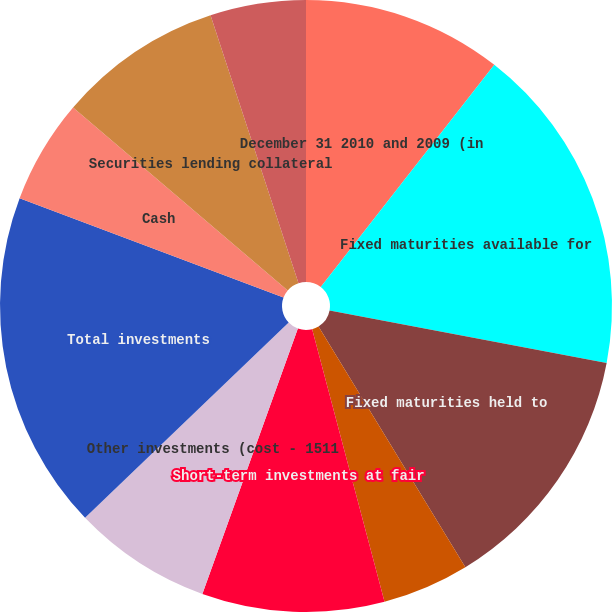Convert chart to OTSL. <chart><loc_0><loc_0><loc_500><loc_500><pie_chart><fcel>December 31 2010 and 2009 (in<fcel>Fixed maturities available for<fcel>Fixed maturities held to<fcel>Equity securities at fair<fcel>Short-term investments at fair<fcel>Other investments (cost - 1511<fcel>Total investments<fcel>Cash<fcel>Securities lending collateral<fcel>Accrued investment income<nl><fcel>10.55%<fcel>17.43%<fcel>13.3%<fcel>4.59%<fcel>9.63%<fcel>7.34%<fcel>17.89%<fcel>5.5%<fcel>8.72%<fcel>5.05%<nl></chart> 